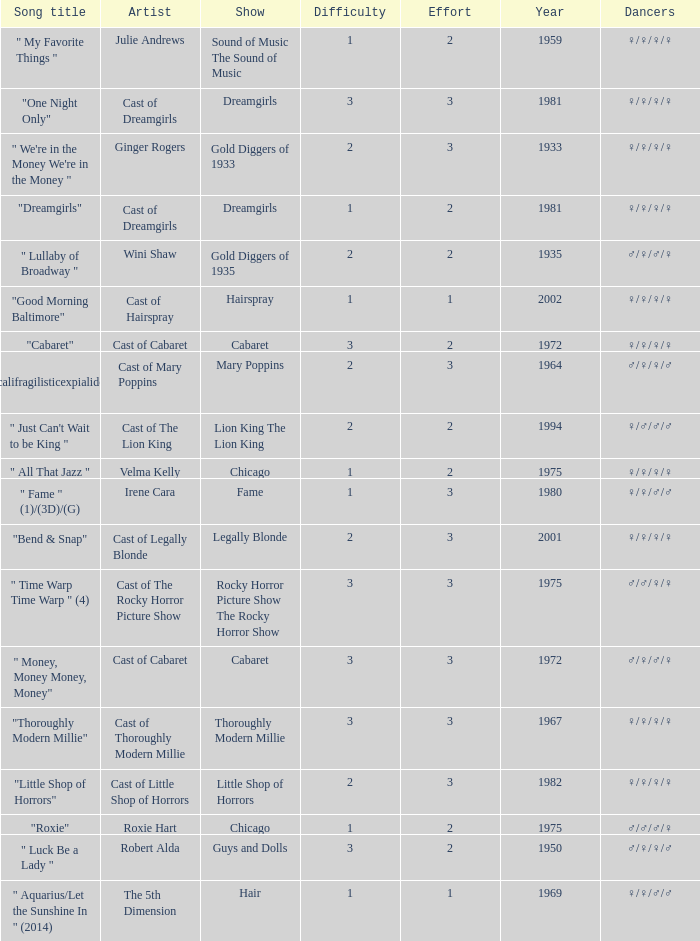How many shows were in 1994? 1.0. Would you mind parsing the complete table? {'header': ['Song title', 'Artist', 'Show', 'Difficulty', 'Effort', 'Year', 'Dancers'], 'rows': [['" My Favorite Things "', 'Julie Andrews', 'Sound of Music The Sound of Music', '1', '2', '1959', '♀/♀/♀/♀'], ['"One Night Only"', 'Cast of Dreamgirls', 'Dreamgirls', '3', '3', '1981', '♀/♀/♀/♀'], ['" We\'re in the Money We\'re in the Money "', 'Ginger Rogers', 'Gold Diggers of 1933', '2', '3', '1933', '♀/♀/♀/♀'], ['"Dreamgirls"', 'Cast of Dreamgirls', 'Dreamgirls', '1', '2', '1981', '♀/♀/♀/♀'], ['" Lullaby of Broadway "', 'Wini Shaw', 'Gold Diggers of 1935', '2', '2', '1935', '♂/♀/♂/♀'], ['"Good Morning Baltimore"', 'Cast of Hairspray', 'Hairspray', '1', '1', '2002', '♀/♀/♀/♀'], ['"Cabaret"', 'Cast of Cabaret', 'Cabaret', '3', '2', '1972', '♀/♀/♀/♀'], ['" Supercalifragilisticexpialidocious " (DP)', 'Cast of Mary Poppins', 'Mary Poppins', '2', '3', '1964', '♂/♀/♀/♂'], ['" Just Can\'t Wait to be King "', 'Cast of The Lion King', 'Lion King The Lion King', '2', '2', '1994', '♀/♂/♂/♂'], ['" All That Jazz "', 'Velma Kelly', 'Chicago', '1', '2', '1975', '♀/♀/♀/♀'], ['" Fame " (1)/(3D)/(G)', 'Irene Cara', 'Fame', '1', '3', '1980', '♀/♀/♂/♂'], ['"Bend & Snap"', 'Cast of Legally Blonde', 'Legally Blonde', '2', '3', '2001', '♀/♀/♀/♀'], ['" Time Warp Time Warp " (4)', 'Cast of The Rocky Horror Picture Show', 'Rocky Horror Picture Show The Rocky Horror Show', '3', '3', '1975', '♂/♂/♀/♀'], ['" Money, Money Money, Money"', 'Cast of Cabaret', 'Cabaret', '3', '3', '1972', '♂/♀/♂/♀'], ['"Thoroughly Modern Millie"', 'Cast of Thoroughly Modern Millie', 'Thoroughly Modern Millie', '3', '3', '1967', '♀/♀/♀/♀'], ['"Little Shop of Horrors"', 'Cast of Little Shop of Horrors', 'Little Shop of Horrors', '2', '3', '1982', '♀/♀/♀/♀'], ['"Roxie"', 'Roxie Hart', 'Chicago', '1', '2', '1975', '♂/♂/♂/♀'], ['" Luck Be a Lady "', 'Robert Alda', 'Guys and Dolls', '3', '2', '1950', '♂/♀/♀/♂'], ['" Aquarius/Let the Sunshine In " (2014)', 'The 5th Dimension', 'Hair', '1', '1', '1969', '♀/♀/♂/♂']]} 